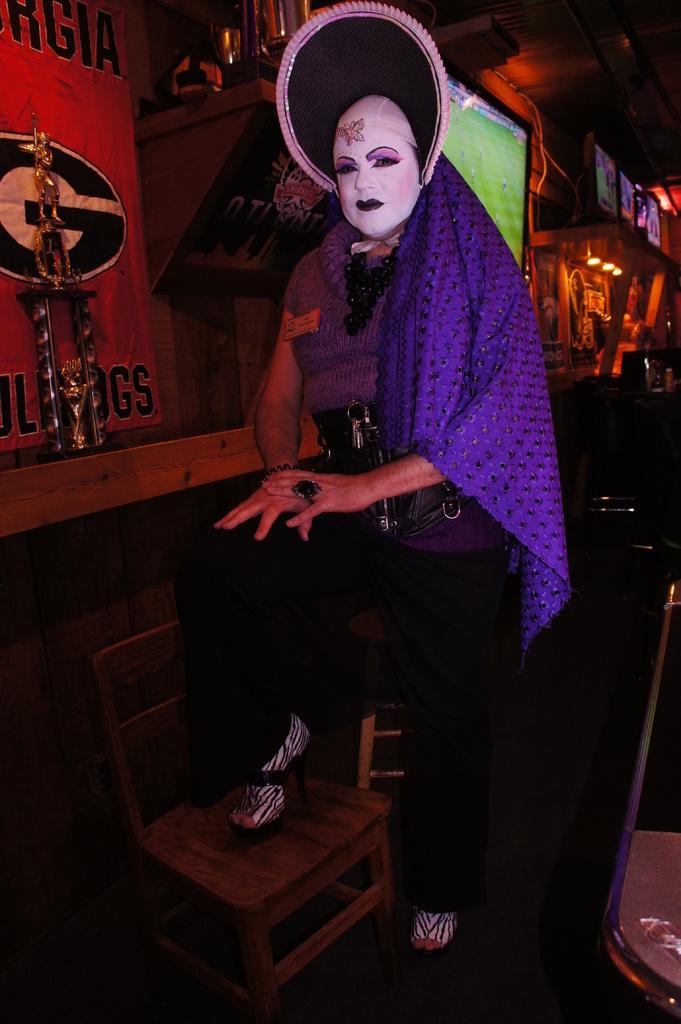Can you describe this image briefly? In this picture we can see a person wore a costume, chair on the floor, poster, statue and at the back of this person we can see screens, lights and some objects. 